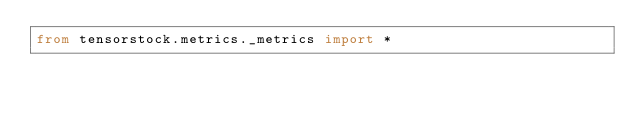Convert code to text. <code><loc_0><loc_0><loc_500><loc_500><_Python_>from tensorstock.metrics._metrics import *</code> 